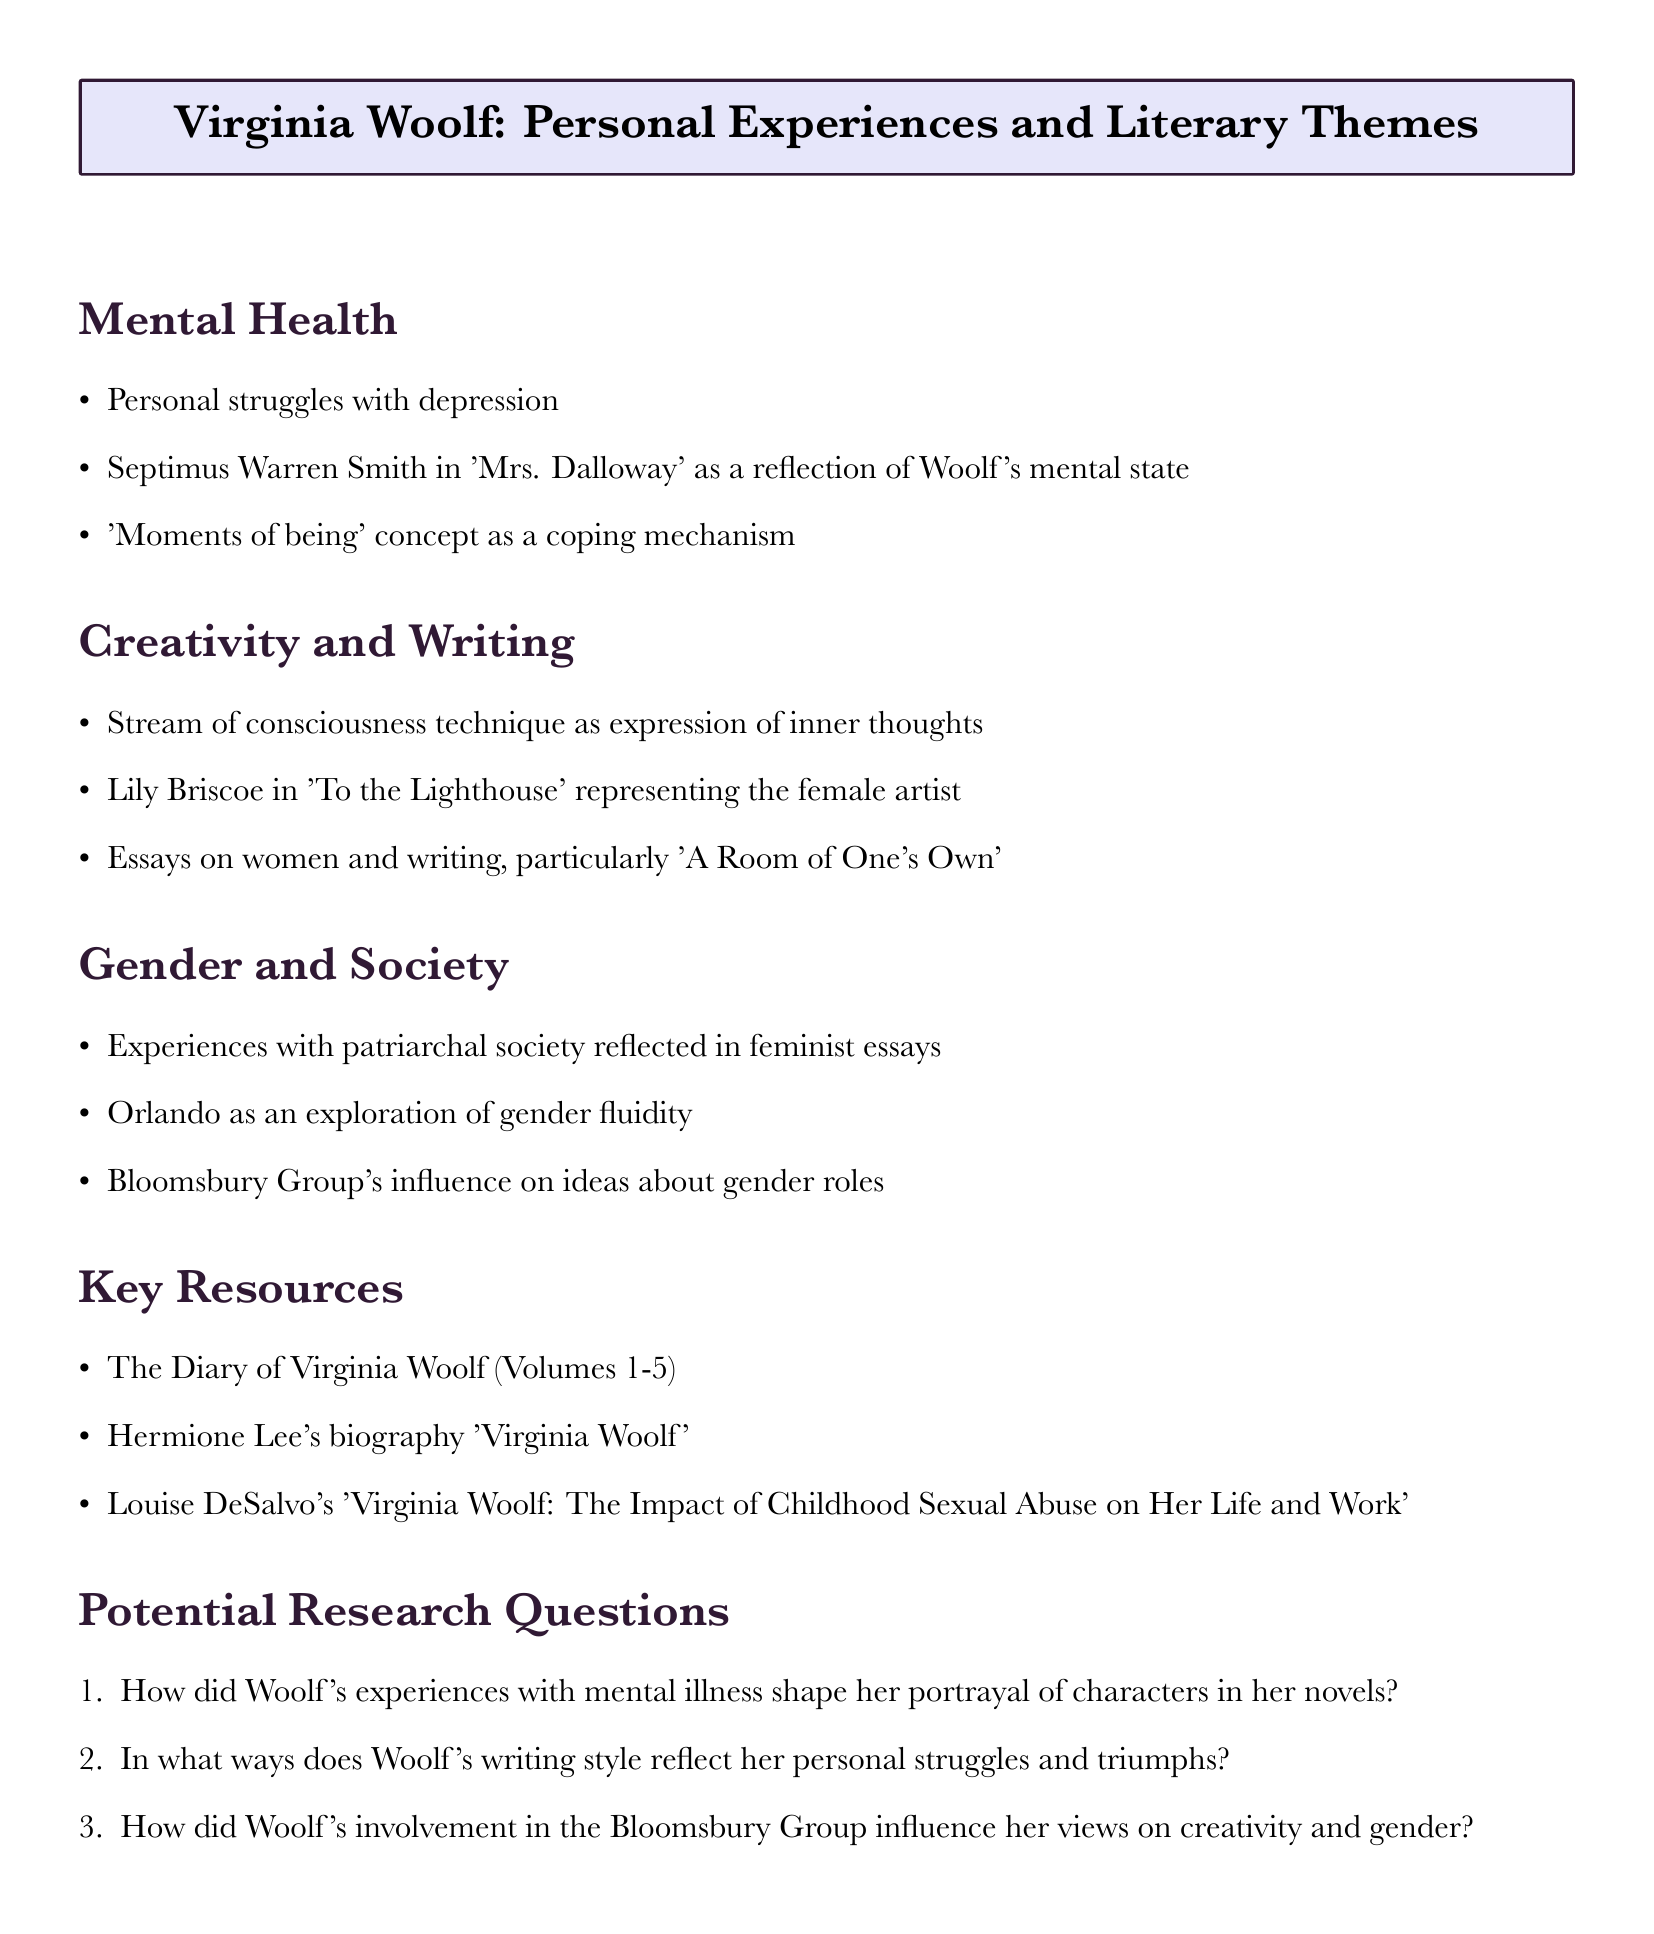What is the first theme discussed in the document? The first theme mentioned is "Mental Health," as it is listed at the beginning of the thematic sections.
Answer: Mental Health Who is the character that reflects Woolf's mental state in 'Mrs. Dalloway'? The character that reflects Woolf's mental state is Septimus Warren Smith, directly noted in the connections section of Mental Health.
Answer: Septimus Warren Smith Which character in 'To the Lighthouse' represents the female artist? The character representing the female artist in 'To the Lighthouse' is Lily Briscoe, as stated in the Creativity and Writing section.
Answer: Lily Briscoe What is one of the key resources mentioned for research on Virginia Woolf? The document lists "The Diary of Virginia Woolf (Volumes 1-5)" as one of the key resources, providing significant insight into her life and work.
Answer: The Diary of Virginia Woolf (Volumes 1-5) How many potential research questions are included in the document? The document includes three potential research questions, enumerated in the specific section.
Answer: 3 What literary device does Woolf use as an expression of her inner thoughts? The literary device noted for expressing Woolf's inner thoughts is the "stream of consciousness technique."
Answer: Stream of consciousness technique What group was Woolf involved with that influenced her ideas about gender roles? Woolf was involved in the "Bloomsbury Group," as mentioned in the Gender and Society section of the document.
Answer: Bloomsbury Group What concept does Woolf use as a coping mechanism in her works? The concept used by Woolf as a coping mechanism is the "moments of being," as highlighted in the Mental Health thematic connections.
Answer: Moments of being In which essay does Woolf discuss women and writing? Woolf discusses women and writing in "A Room of One's Own," explicitly mentioned in the Creativity and Writing section.
Answer: A Room of One's Own 